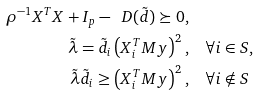<formula> <loc_0><loc_0><loc_500><loc_500>\rho ^ { - 1 } X ^ { T } X + I _ { p } - \ D ( \tilde { d } ) \succeq 0 , & \\ \tilde { \lambda } = \tilde { d } _ { i } \left ( X _ { i } ^ { T } M y \right ) ^ { 2 } , & \quad \forall i \in S , \\ \tilde { \lambda } \tilde { d } _ { i } \geq \left ( X _ { i } ^ { T } M y \right ) ^ { 2 } , & \quad \forall i \notin S</formula> 